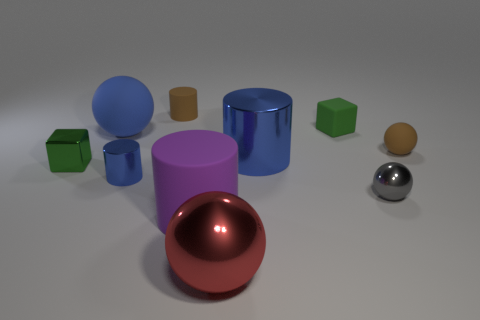Subtract all big purple cylinders. How many cylinders are left? 3 Subtract all spheres. How many objects are left? 6 Subtract 1 cylinders. How many cylinders are left? 3 Subtract all red balls. How many balls are left? 3 Add 4 big purple objects. How many big purple objects are left? 5 Add 3 big green metal objects. How many big green metal objects exist? 3 Subtract 1 brown cylinders. How many objects are left? 9 Subtract all purple spheres. Subtract all blue cylinders. How many spheres are left? 4 Subtract all gray balls. How many yellow cylinders are left? 0 Subtract all matte spheres. Subtract all large brown things. How many objects are left? 8 